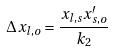Convert formula to latex. <formula><loc_0><loc_0><loc_500><loc_500>\Delta x _ { l , o } = \frac { x _ { l , s } x _ { s , o } ^ { \prime } } { k _ { 2 } }</formula> 